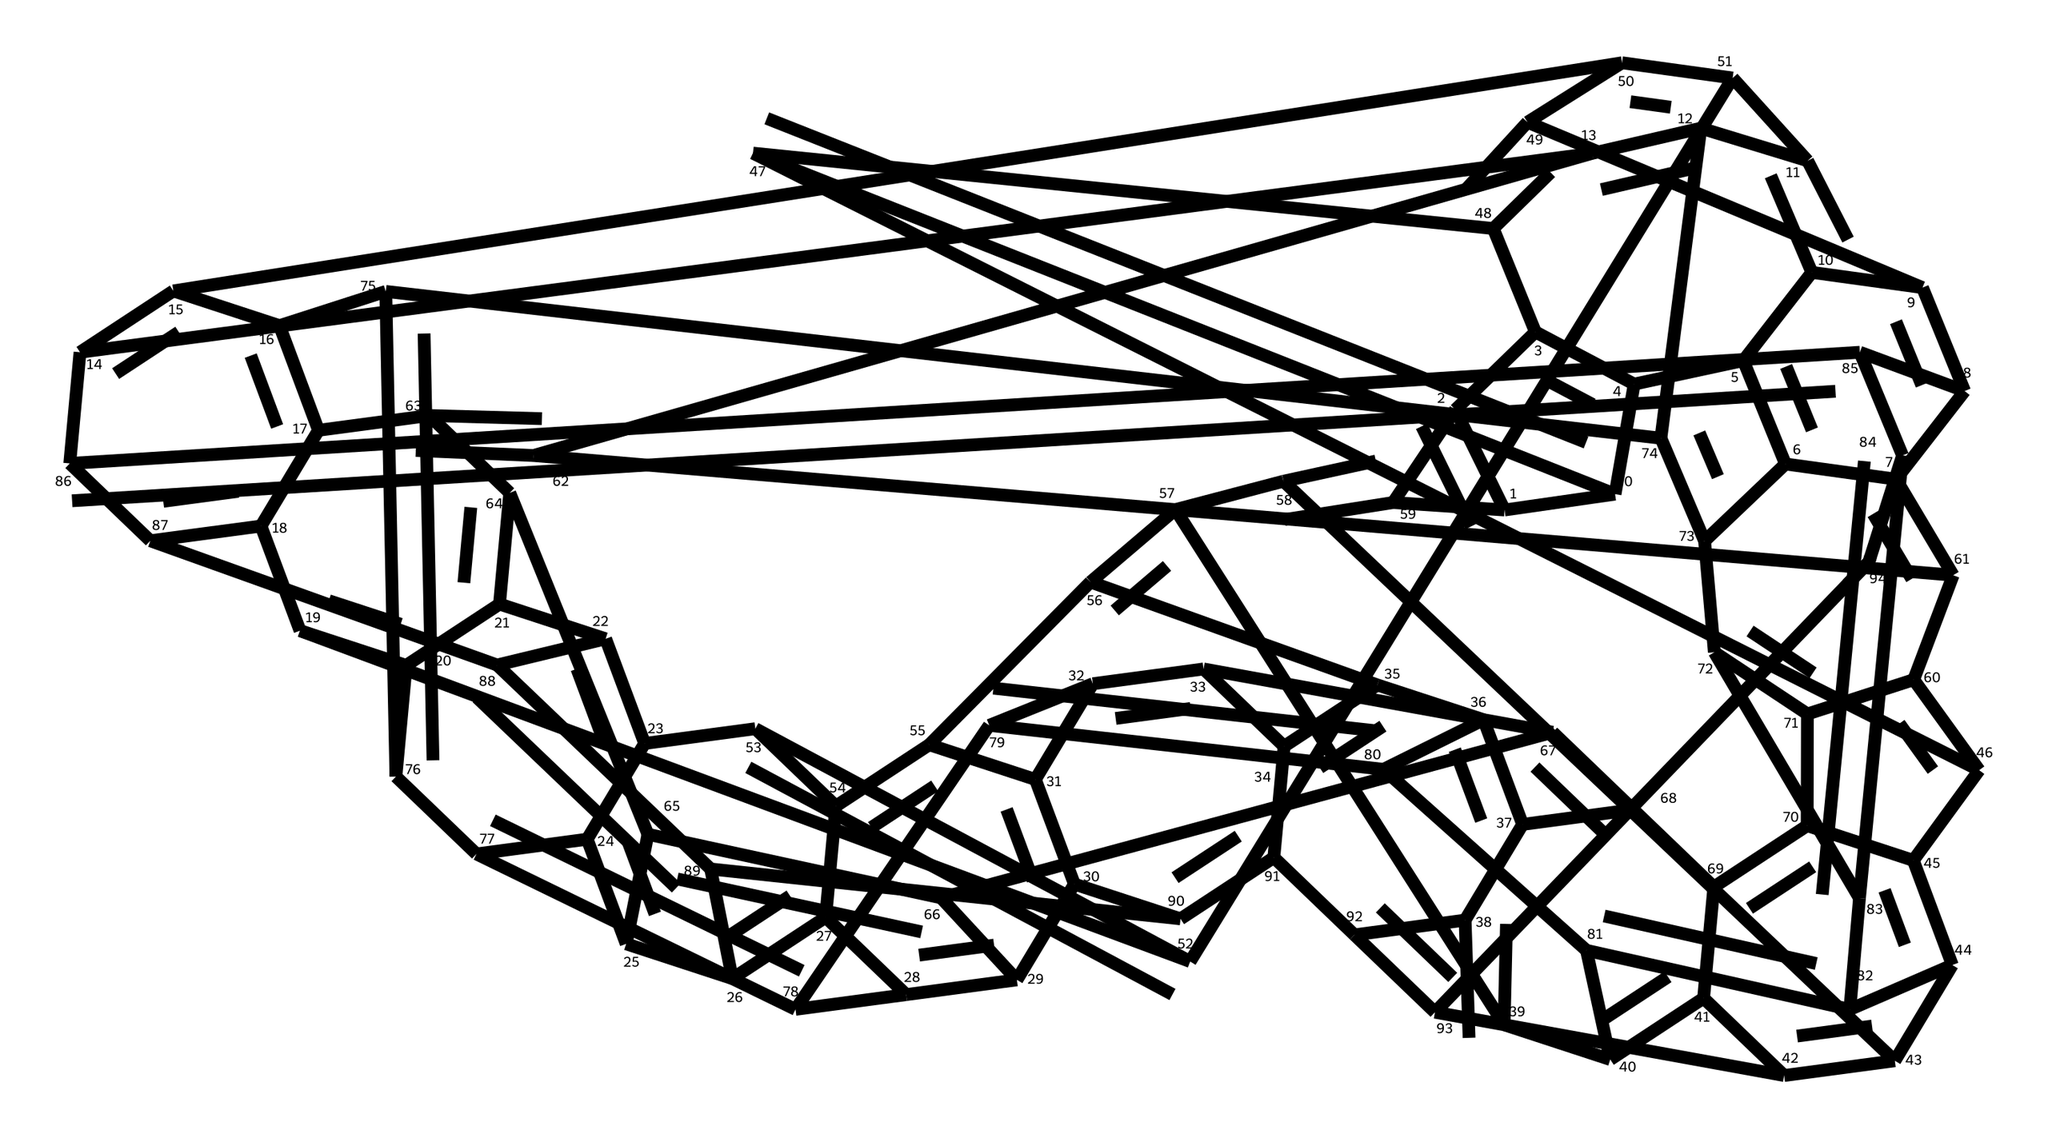What is the primary molecular shape of the compound? The compound is a fullerene, characterized by a spherical or cage-like arrangement of carbon atoms. This is evident from the arrangement of the carbon atoms in hexagonal and pentagonal configurations that define fullerenes.
Answer: spherical How many carbon atoms are in the structure? By visually counting the carbon atoms represented in the structure or deducing from the SMILES notation, we can determine the total number of carbon atoms present. In this case, there are 60 carbon atoms observed.
Answer: 60 What type of chemical bonds are primarily present? The structure of the compound indicates that it contains primarily covalent bonds, which can be inferred from the connectivity of the carbon atoms in a chain-like and cyclical manner without any indication of ionic characteristics.
Answer: covalent Are there any specific applications of this compound in energetic materials? Fullerenes, such as this compound, have been studied for their potential use in energetic materials due to their unique structural properties, which can influence energy release mechanisms during reactions.
Answer: energetic materials What is the significance of the pentagonal faces in the structure? Pentagonal faces in the structure are crucial for maintaining the overall stability and geometric integrity of the fullerene. This is because they contribute to the curvature necessary for the spherical shape, which is a uniqueness of fullerene molecules.
Answer: stability How does this compound differ from other carbon allotropes? Unlike other carbon allotropes such as graphite and diamond, which have planar or extended network structures, this compound's three-dimensional cage structure defines its properties and behavior, making it distinct from typical carbon allotropes.
Answer: cage structure 